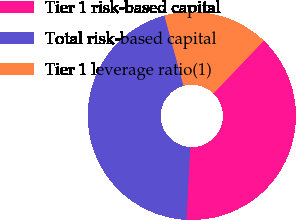<chart> <loc_0><loc_0><loc_500><loc_500><pie_chart><fcel>Tier 1 risk-based capital<fcel>Total risk-based capital<fcel>Tier 1 leverage ratio(1)<nl><fcel>38.7%<fcel>44.92%<fcel>16.38%<nl></chart> 